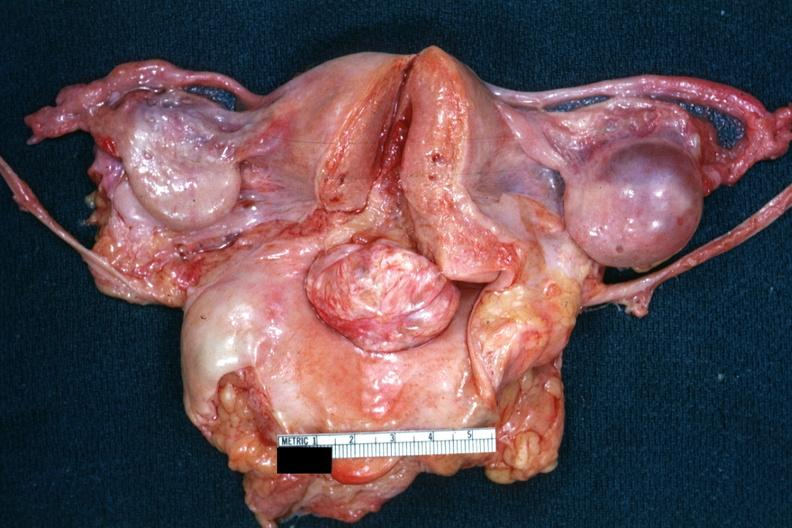what does this image show?
Answer the question using a single word or phrase. Opened uterus and cervix with large cervical myoma protruding into vagina slide is close-up of cut surface of myoma 